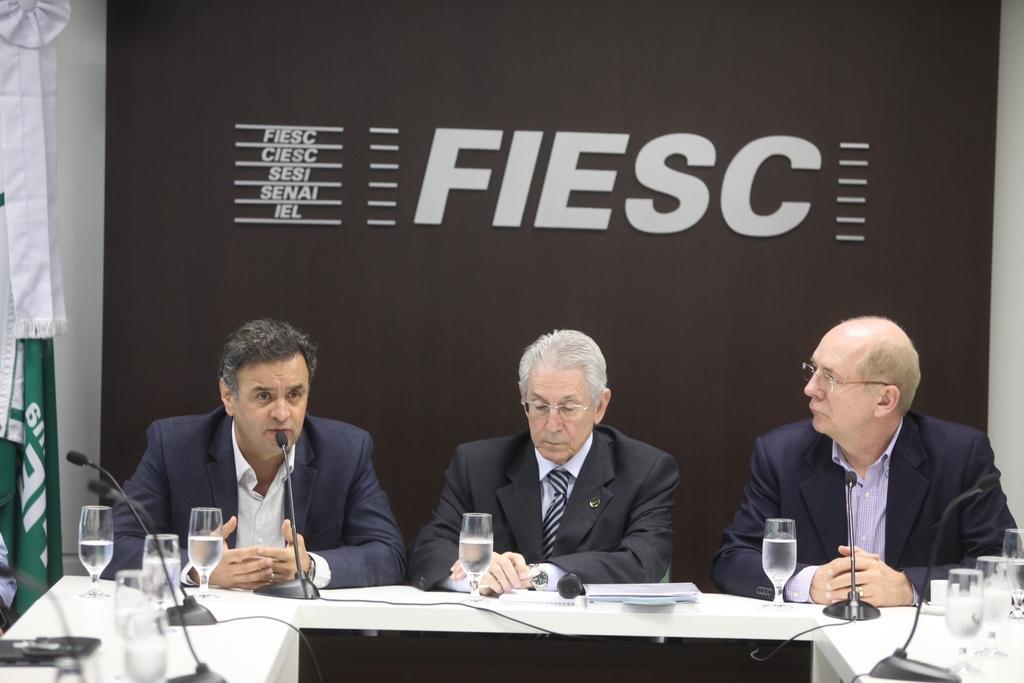Can you describe this image briefly? In this image we can see a group of people are sitting on the chair, and in front here is the table and glass and some objects on it. 